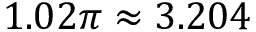Convert formula to latex. <formula><loc_0><loc_0><loc_500><loc_500>1 . 0 2 \pi \approx 3 . 2 0 4</formula> 